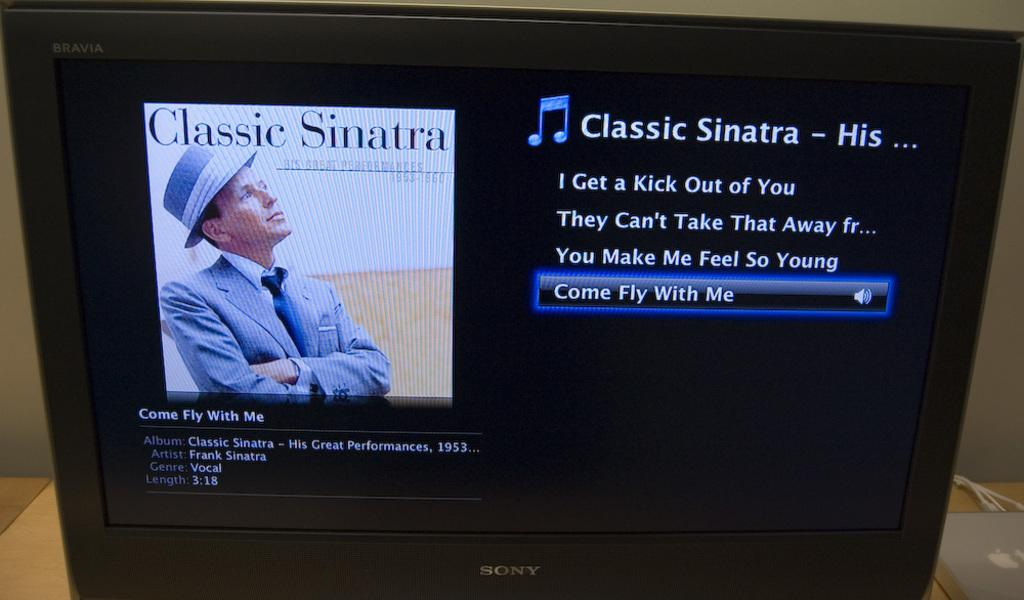<image>
Offer a succinct explanation of the picture presented. a sony flat screen tv tuned into a frank sinatra playlist 